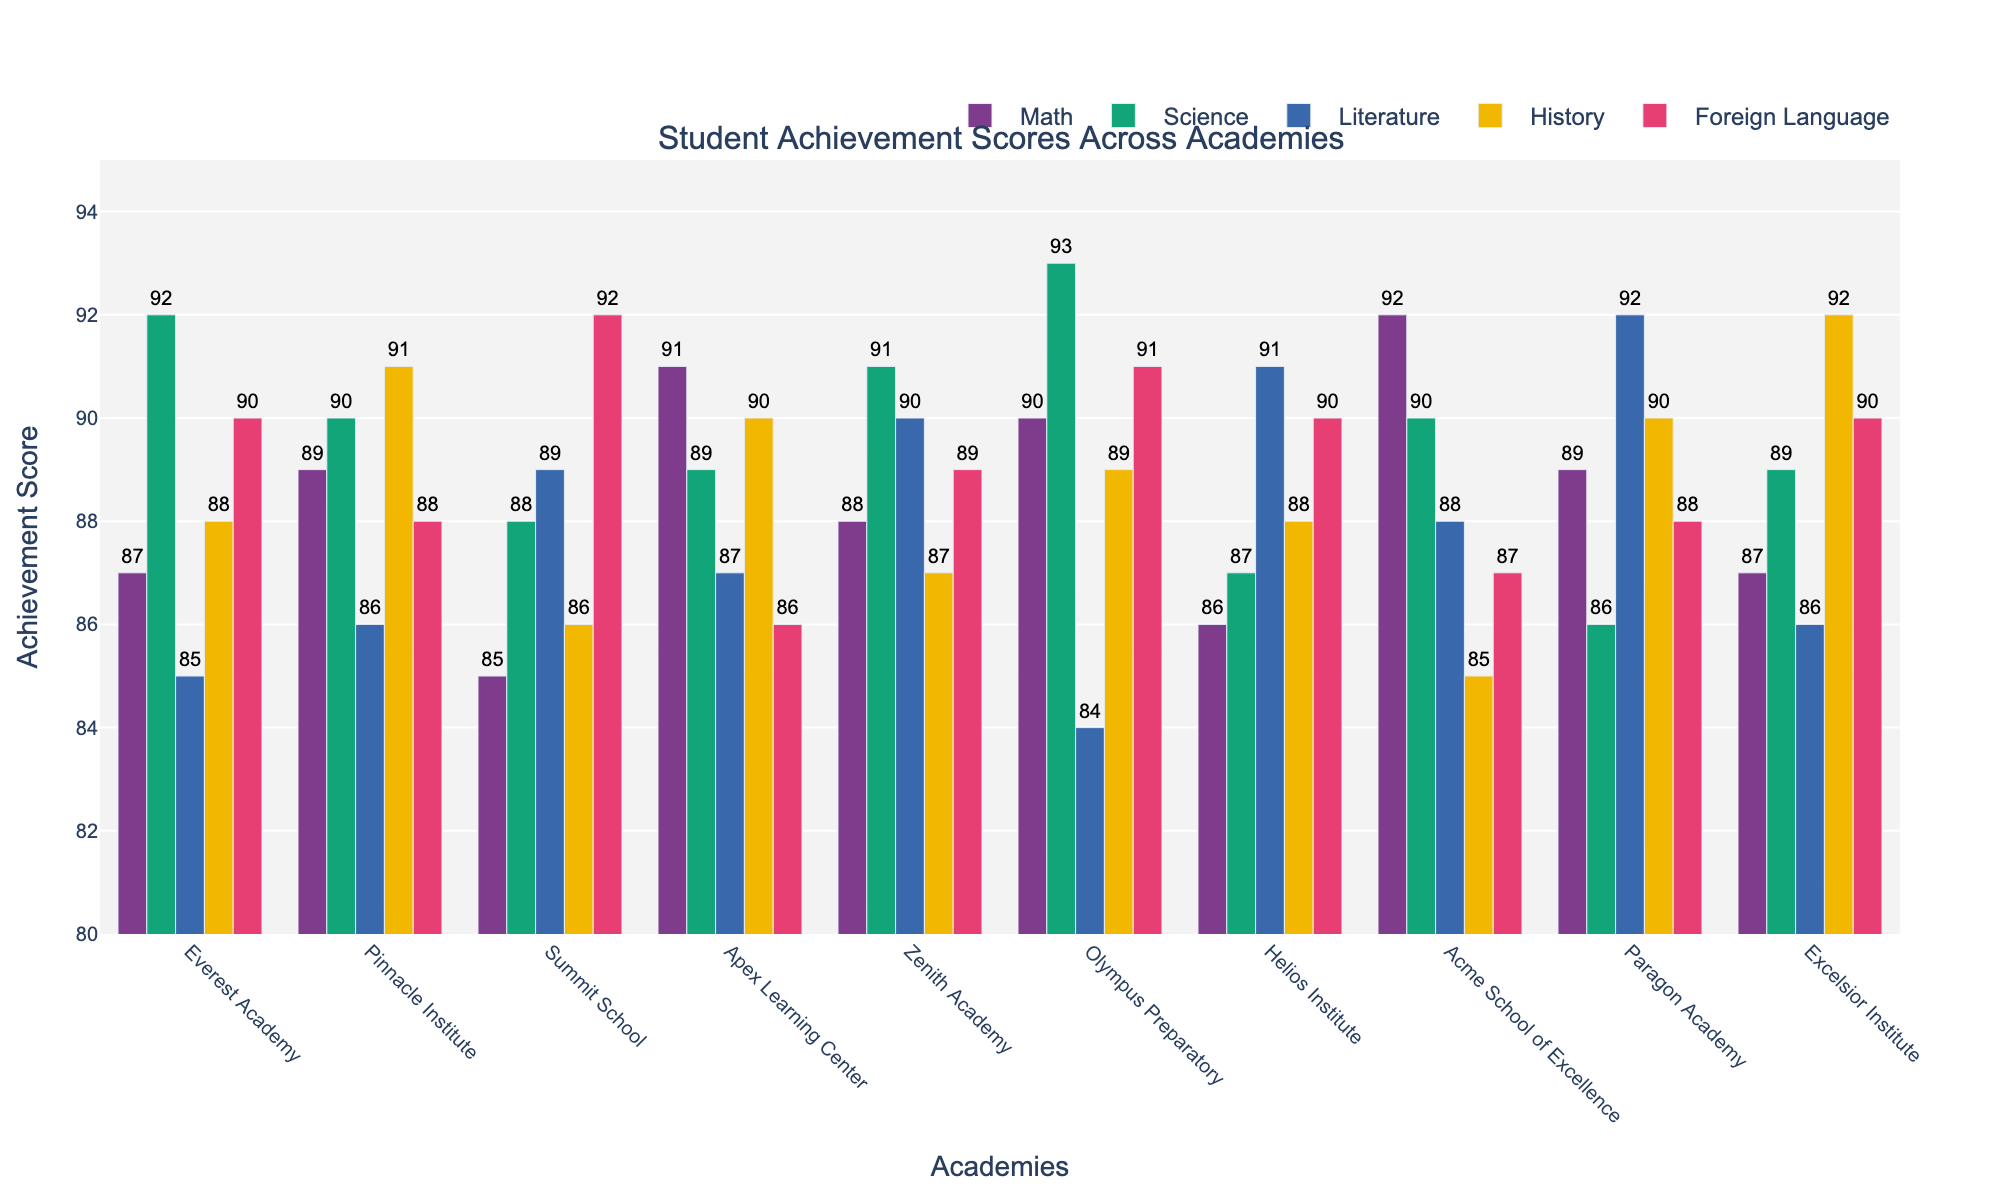Which academy scored highest in Science? To find the academy with the highest score in Science, look at the height of the bars corresponding to Science for each academy. Everest Academy, Olympus Preparatory, and Zenith Academy have the tallest bars, all at 93.
Answer: Olympus Preparatory Which academy has the lowest score in Literature? To identify the academy with the lowest Literature score, check the length of the Literature bars for each academy. Olympus Preparatory has the shortest Literature bar at 84.
Answer: Olympus Preparatory What is the average Math score across all academies? Add up the Math scores of all academies and then divide by the number of academies. The total Math score is 87 + 89 + 85 + 91 + 88 + 90 + 86 + 92 + 89 + 87 = 874. Divide 874 by 10 (number of academies) to get the average: 874/10 = 87.4.
Answer: 87.4 Which subject has the most number of academies scoring above 90? For each subject, count the number of academies with scores above 90. Math: 2, Science: 3, Literature: 1, History: 2, Foreign Language: 3. Science and Foreign Language both have 3 academies scoring above 90.
Answer: Science and Foreign Language How much higher is the highest score in Math compared to the lowest score in Math? Identify the highest Math score (92 at Acme School of Excellence) and the lowest Math score (85 at Summit School). Subtract the lowest score from the highest score: 92 - 85 = 7.
Answer: 7 Which academy has the most consistent scores across all subjects? Check the variation range for each academy's scores. Summit School scores vary between 85 and 92, while the scores for other academies show a wider range.
Answer: Summit School What is the median Literature score across all academies? List the Literature scores in ascending order: 84, 85, 86, 86, 87, 88, 88, 89, 90, 92. The median is the average of the 5th and 6th scores: (87 + 88)/2 = 87.5.
Answer: 87.5 Which academy has the highest combined score for Math and Science? Calculate the combined Math and Science score for each academy and determine the highest. For Acme School of Excellence, it's 92 + 90 = 182. For others, check similarly. Acme School of Excellence has the highest combined score.
Answer: Acme School of Excellence 